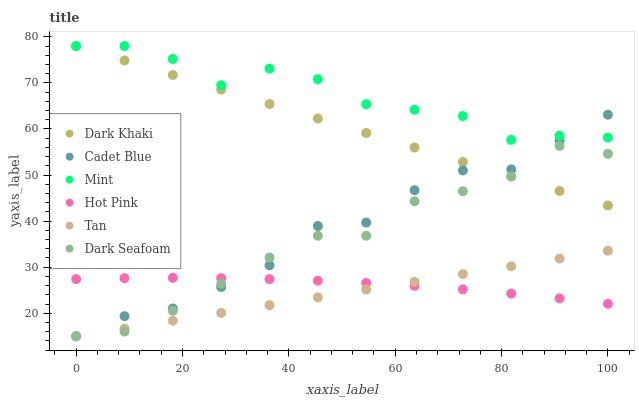Does Tan have the minimum area under the curve?
Answer yes or no. Yes. Does Mint have the maximum area under the curve?
Answer yes or no. Yes. Does Hot Pink have the minimum area under the curve?
Answer yes or no. No. Does Hot Pink have the maximum area under the curve?
Answer yes or no. No. Is Tan the smoothest?
Answer yes or no. Yes. Is Mint the roughest?
Answer yes or no. Yes. Is Hot Pink the smoothest?
Answer yes or no. No. Is Hot Pink the roughest?
Answer yes or no. No. Does Cadet Blue have the lowest value?
Answer yes or no. Yes. Does Hot Pink have the lowest value?
Answer yes or no. No. Does Mint have the highest value?
Answer yes or no. Yes. Does Hot Pink have the highest value?
Answer yes or no. No. Is Hot Pink less than Dark Khaki?
Answer yes or no. Yes. Is Mint greater than Dark Seafoam?
Answer yes or no. Yes. Does Cadet Blue intersect Tan?
Answer yes or no. Yes. Is Cadet Blue less than Tan?
Answer yes or no. No. Is Cadet Blue greater than Tan?
Answer yes or no. No. Does Hot Pink intersect Dark Khaki?
Answer yes or no. No. 